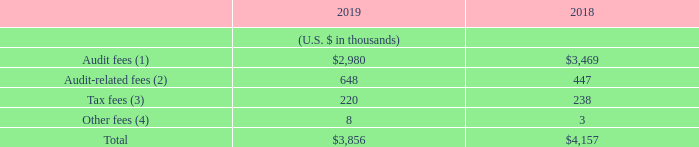Item 16C. PRINCIPAL ACCOUNTANT FEES AND SERVICES
Aggregate audit fees, audit-related fees, tax fees and the aggregate of all other fees billed to us by Ernst & Young LLP for the fiscal years ended June 30, 2019 and 2018 were as follows:
(1) Audit Fees consist of fees incurred for professional services rendered for the integrated audit of our annual consolidated financial statements, review of the quarterly consolidated financial statements and foreign statutory audits and services that are normally provided by Ernst & Young LLP in connection with statutory and regulatory filings or engagements. Audit fees also include accounting consultations, research related to the integrated audit and comfort letter services in relation to our exchangeable senior notes.
(2) Audit-Related Fees consist of fees billed for assurance and related services that are reasonably related to the performance of the audit or review of the Company’s consolidated financial statements and are not reported under “Audit Fees.” This primarily consists of fees for service organization control audits and due diligence on acquisitions.
(3) Tax fees relate to assistance with tax compliance, tax planning and various tax advisory services.
(4) Other fees are any additional amounts for products and services provided by the principal accountants.
Our audit committee has adopted a pre-approval policy for the engagement of our independent accountant to perform certain audit and non-audit services. Pursuant to this policy, which is designed to assure that such engagements do not impair the independence of our auditors, the audit committee pre-approves annually all audit services, audit related services, tax services and other services as described above, that may be performed by our independent accountants. All of the audit and non-audit services provided by our principal accountants have been pre-approved by our Audit Committee.
What is the definition of other fees? Any additional amounts for products and services provided by the principal accountants. What does tax fees refer to? Assistance with tax compliance, tax planning and various tax advisory services. What is the total fees for fiscal year ended June 30, 2019?
Answer scale should be: thousand. $3,856. What is the change in total fees between fiscal years 2018 and 2019?
Answer scale should be: thousand. 3,856-4,157
Answer: -301. What is the average tax fees for fiscal years 2018 and 2019?
Answer scale should be: thousand. (220+238)/2
Answer: 229. For fiscal year ended June 30, 2018, what is the percentage constitution of audit fees among the total fees?
Answer scale should be: percent. 3,469/4,157
Answer: 83.45. 